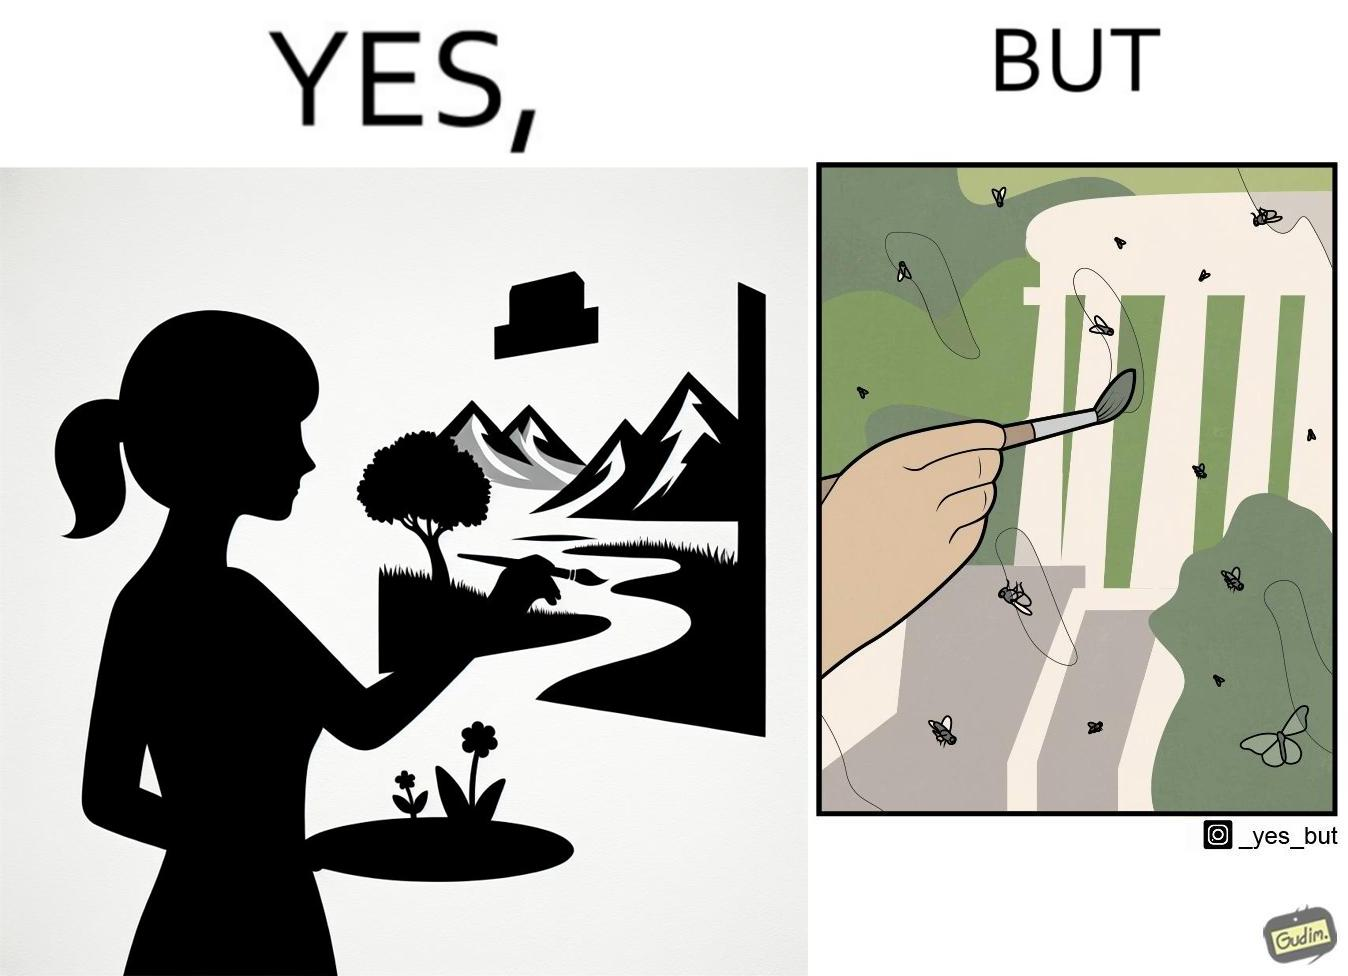Is this a satirical image? Yes, this image is satirical. 